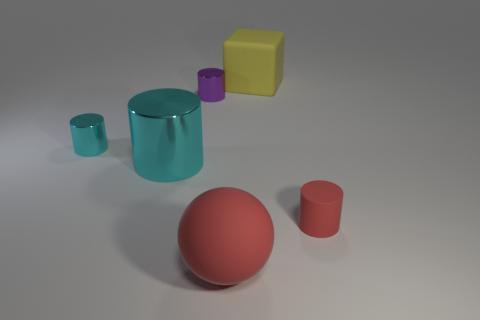Is the number of big yellow matte objects in front of the big shiny thing the same as the number of objects right of the red matte cylinder?
Your answer should be compact. Yes. Is the purple metallic thing the same shape as the yellow rubber object?
Offer a terse response. No. The big object that is on the right side of the purple object and in front of the yellow matte cube is made of what material?
Your answer should be compact. Rubber. How many tiny purple things have the same shape as the big red matte thing?
Give a very brief answer. 0. There is a red rubber thing that is right of the red thing that is on the left side of the small cylinder to the right of the tiny purple cylinder; what size is it?
Offer a very short reply. Small. Is the number of objects behind the large matte ball greater than the number of brown matte spheres?
Your answer should be very brief. Yes. Are any red cubes visible?
Offer a terse response. No. What number of yellow objects have the same size as the block?
Your answer should be very brief. 0. Are there more tiny red rubber objects behind the red rubber cylinder than small metallic cylinders in front of the purple metal cylinder?
Offer a very short reply. No. There is a cyan thing that is the same size as the red cylinder; what material is it?
Your answer should be compact. Metal. 